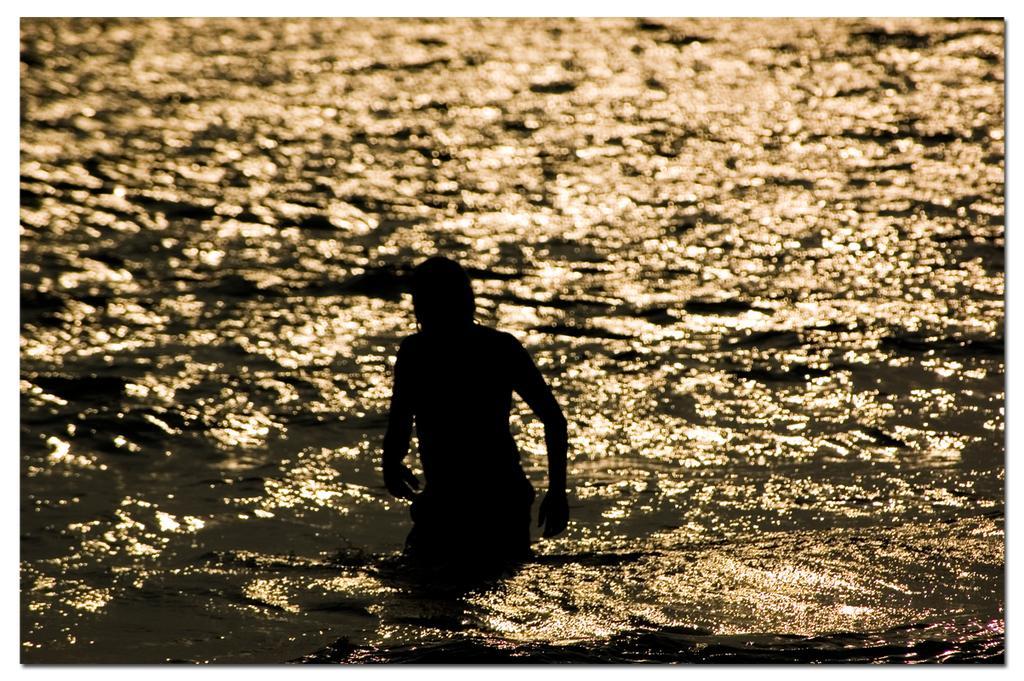Describe this image in one or two sentences. In this picture we can see the water and a person is visible. 